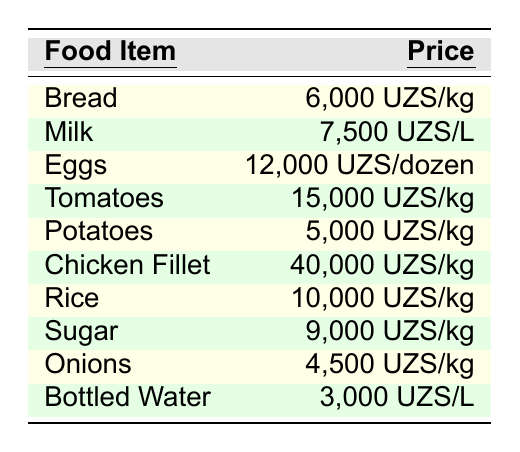What is the price of potatoes per kilogram? The table shows that potatoes are priced at 5,000 UZS per kilogram.
Answer: 5,000 UZS/kg Which item is the most expensive per kilogram? By reviewing the prices in the table, chicken fillet is listed as the highest at 40,000 UZS per kilogram.
Answer: Chicken Fillet How much do a dozen eggs cost? According to the table, the price for a dozen eggs is 12,000 UZS.
Answer: 12,000 UZS Is the price of bottled water higher than that of sugar? The table shows bottled water costs 3,000 UZS per liter and sugar costs 9,000 UZS per kilogram. Since 3,000 UZS is less than 9,000 UZS, the statement is false.
Answer: No What is the total price for 1 kg of rice and 1 kg of tomatoes? Rice costs 10,000 UZS/kg and tomatoes cost 15,000 UZS/kg. Summing these gives 10,000 + 15,000 = 25,000 UZS as the total.
Answer: 25,000 UZS How much cheaper are onions compared to chicken fillet per kg? Onions are priced at 4,500 UZS/kg while chicken fillet is 40,000 UZS/kg. The difference is 40,000 - 4,500 = 35,500 UZS, indicating that onions are much cheaper.
Answer: 35,500 UZS What is the average price of potatoes, tomatoes, and rice? Potatoes cost 5,000 UZS, tomatoes 15,000 UZS, and rice 10,000 UZS. Adding these gives 5,000 + 15,000 + 10,000 = 30,000 UZS. There are 3 items, so the average is 30,000/3 = 10,000 UZS.
Answer: 10,000 UZS How many food items are cheaper than 10,000 UZS per kilogram? The table lists items that are cheaper than 10,000 UZS: bread (6,000 UZS), potatoes (5,000 UZS), and onions (4,500 UZS). This totals to three food items.
Answer: 3 What is the combined price of milk and sugar? Milk is priced at 7,500 UZS per liter and sugar at 9,000 UZS per kilogram. Adding these together results in 7,500 + 9,000 = 16,500 UZS for both.
Answer: 16,500 UZS If you buy 2 kg of chicken fillet, how much will it cost? The price for chicken fillet is 40,000 UZS per kilogram. Therefore, for 2 kg, the cost would be 40,000 x 2 = 80,000 UZS.
Answer: 80,000 UZS 